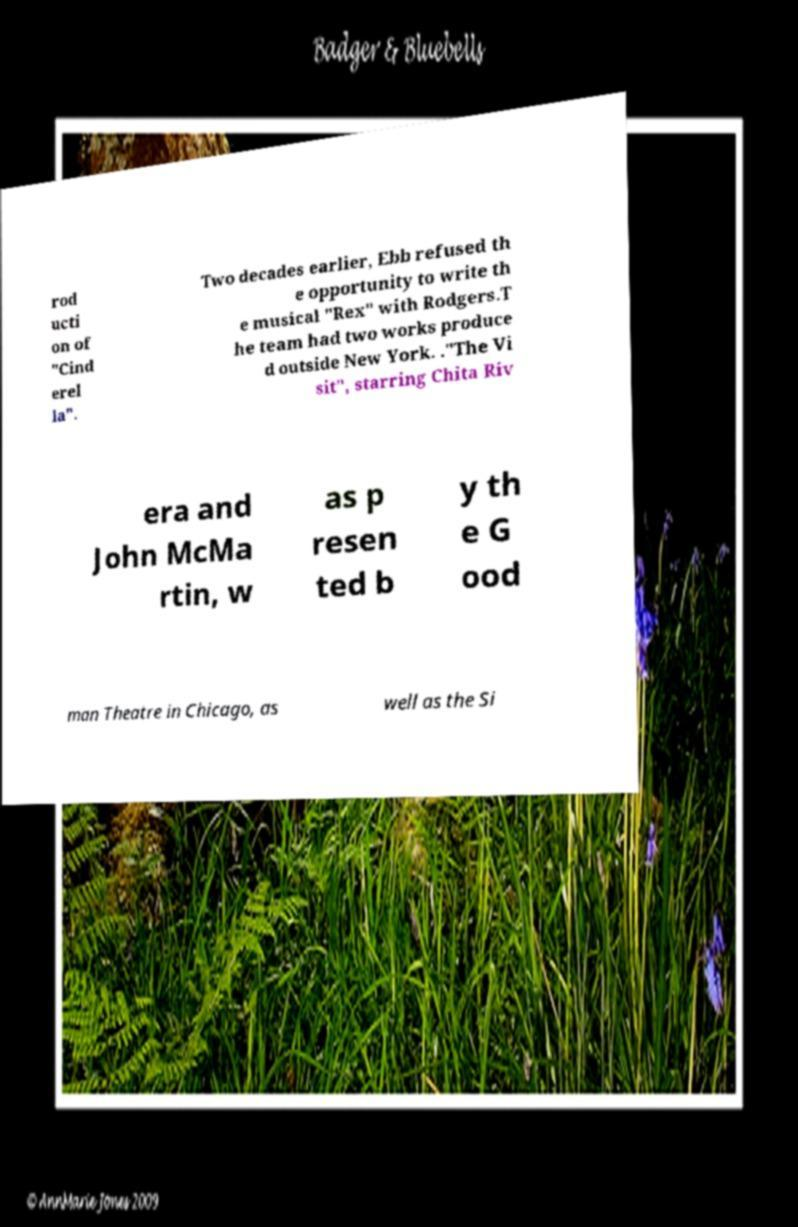Could you extract and type out the text from this image? rod ucti on of "Cind erel la". Two decades earlier, Ebb refused th e opportunity to write th e musical "Rex" with Rodgers.T he team had two works produce d outside New York. ."The Vi sit", starring Chita Riv era and John McMa rtin, w as p resen ted b y th e G ood man Theatre in Chicago, as well as the Si 